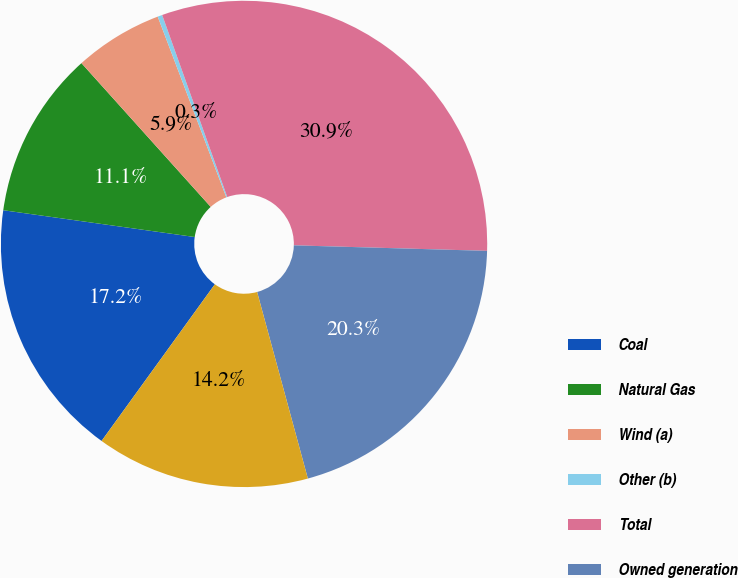<chart> <loc_0><loc_0><loc_500><loc_500><pie_chart><fcel>Coal<fcel>Natural Gas<fcel>Wind (a)<fcel>Other (b)<fcel>Total<fcel>Owned generation<fcel>Purchased generation<nl><fcel>17.25%<fcel>11.13%<fcel>5.88%<fcel>0.31%<fcel>30.92%<fcel>20.32%<fcel>14.19%<nl></chart> 